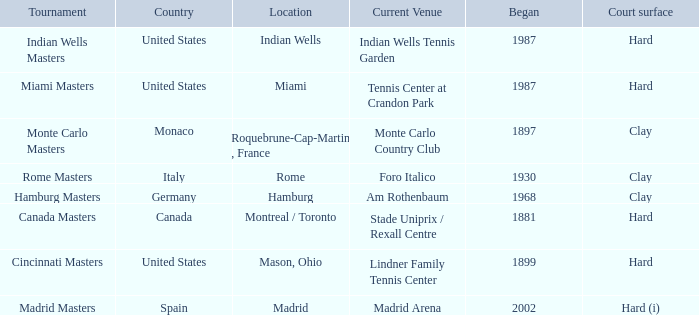What is the present location for the miami masters tournament? Tennis Center at Crandon Park. 